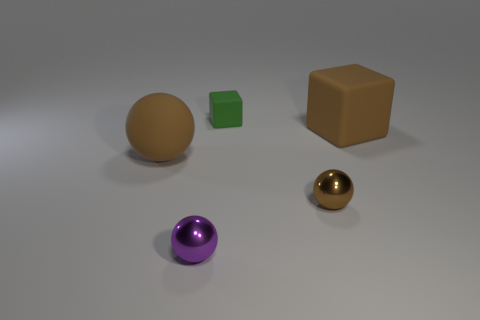What number of big brown objects are the same shape as the small rubber object?
Your response must be concise. 1. Do the tiny purple thing and the large object that is to the left of the brown cube have the same material?
Your answer should be very brief. No. What size is the purple thing that is made of the same material as the small brown ball?
Offer a terse response. Small. How big is the block that is behind the big brown cube?
Your answer should be compact. Small. How many green blocks have the same size as the brown cube?
Your response must be concise. 0. There is another sphere that is the same color as the matte ball; what size is it?
Your answer should be compact. Small. Are there any small things that have the same color as the large sphere?
Keep it short and to the point. Yes. There is a matte thing that is the same size as the purple metal ball; what is its color?
Your answer should be very brief. Green. Do the small matte block and the shiny ball that is on the right side of the tiny purple metal sphere have the same color?
Your response must be concise. No. What color is the tiny matte cube?
Ensure brevity in your answer.  Green. 